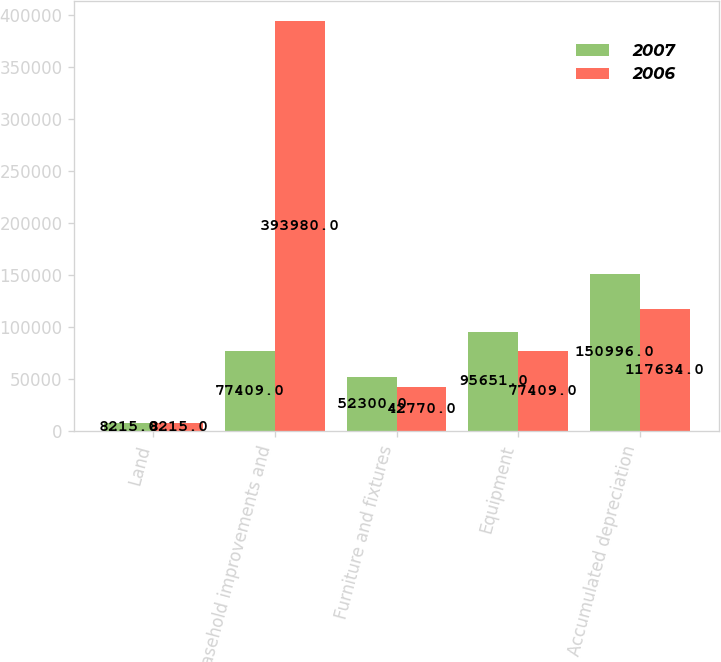Convert chart to OTSL. <chart><loc_0><loc_0><loc_500><loc_500><stacked_bar_chart><ecel><fcel>Land<fcel>Leasehold improvements and<fcel>Furniture and fixtures<fcel>Equipment<fcel>Accumulated depreciation<nl><fcel>2007<fcel>8215<fcel>77409<fcel>52300<fcel>95651<fcel>150996<nl><fcel>2006<fcel>8215<fcel>393980<fcel>42770<fcel>77409<fcel>117634<nl></chart> 